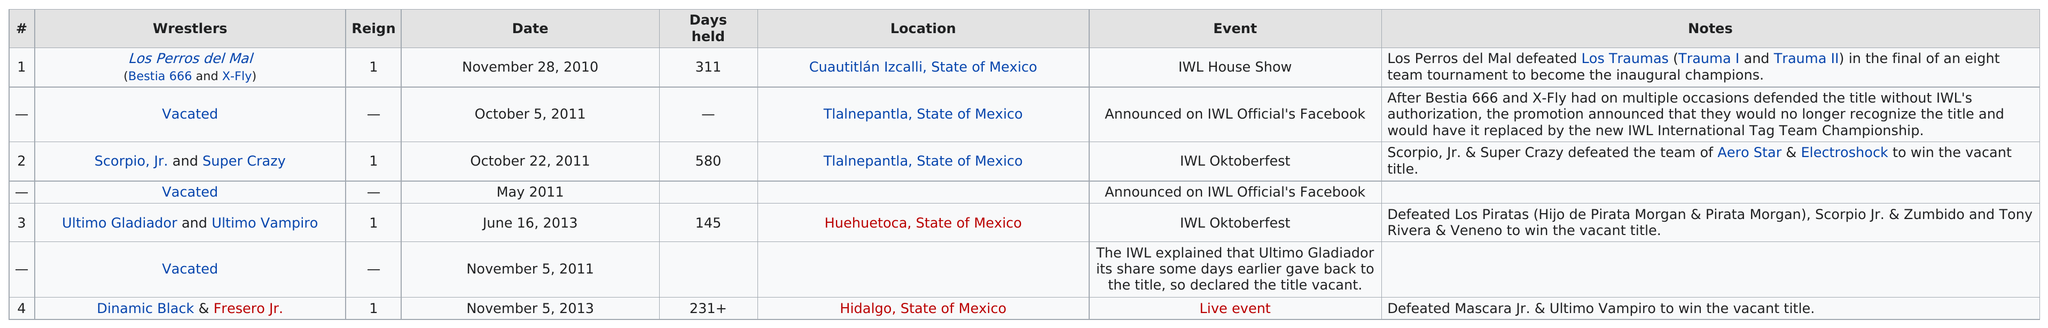Give some essential details in this illustration. In 2011, 4 events were held. I am unable to name a championship that took place at IWL Oktoberfest, other than Scorpio Jr. and Super Crazy, because Ultimo Gladiador and Ultimo Vampiro were also involved. Tlalnepantla, in the State of Mexico, was the location that recorded the highest number of matches. For how many days did Ultimo Gladiador and Ultimo Vampiro hold the World Championship? They held it for a total of 145 days. The title has been vacated two times. 